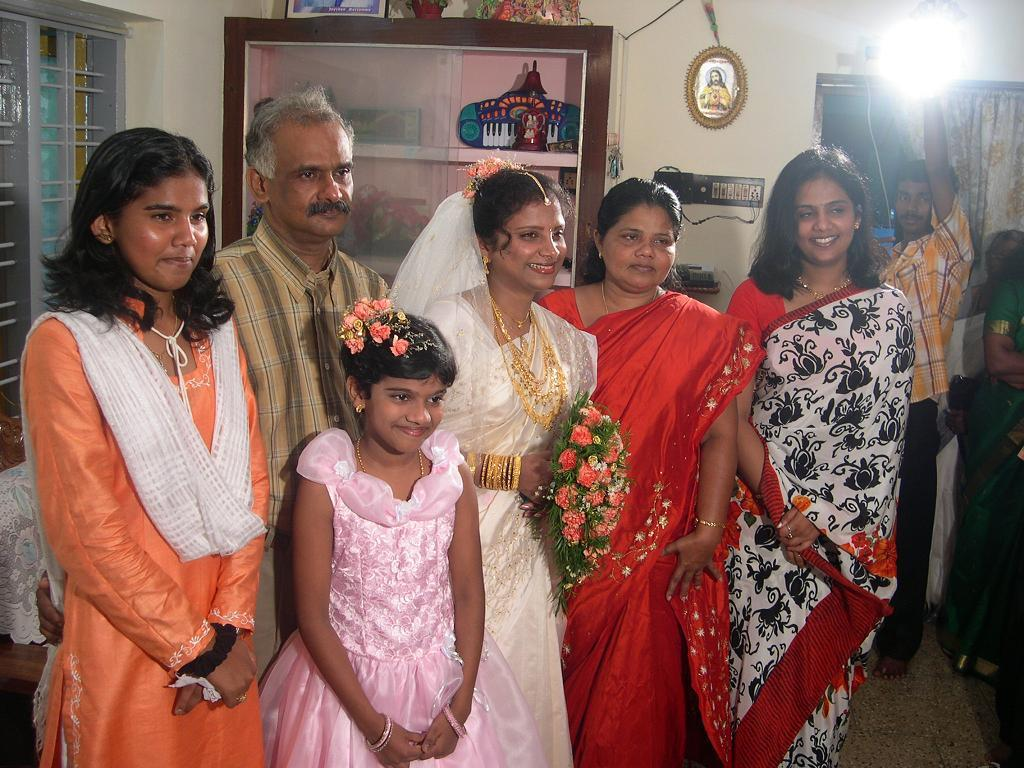What are the people in the image doing? The people in the image are standing on the floor. What can be seen in the background of the image? In the background of the image, there is a window, a wall, a light, a curtain associated with the window, frames, a socket, a cupboard, and other objects. Can you describe the window in the background? The window in the background has a curtain associated with it. What type of object is the socket in the background? The socket in the background is an electrical outlet. What might be the purpose of the frames in the background? The frames in the background might be used to display artwork or photographs. What type of basin is visible in the image? There is no basin present in the image. What type of teeth can be seen in the image? There are no teeth visible in the image. 